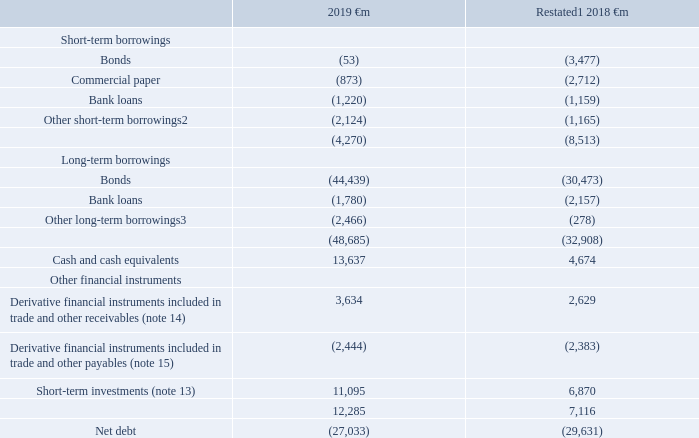20. Borrowings and capital resources
The Group’s sources of borrowing for funding and liquidity purposes come from a range of committed bank facilities and through short-term and long-term issuances in the capital markets including bond and commercial paper issues and bank loans. We manage the basis on which we incur interest on debt between fixed interest rates and floating interest rates depending on market conditions using interest rate derivatives. The Group enters into foreign exchange contracts to mitigate the impact of exchange rate movements on certain monetary items.
This section includes an analysis of net debt, which is used to manage capital
Accounting policies
Interest-bearing loans and overdrafts are initially measured at fair value (which is equal to cost at inception), and are subsequently measured at amortised cost, using the effective interest rate method. Where they are identified as a hedged item in a designated fair value hedge relationship, fair value adjustments are recognised in accordance with policy (see note 21 “Capital and financial risk management”). Any difference between the proceeds net of transaction costs and the amount due on settlement or redemption of borrowings is recognised over the term of the borrowing. Where bonds issued with certain conversion rights are identified as compound instruments they are initially measured at fair value with the nominal amounts recognised as a component in equity and the fair value of future coupons included in borrowings. These are subsequently measured at amortised cost using the effective interest rate method.
Net debt
At 31 March 2019 net debt represented 58% of our market capitalisation (2018: 46%). Average net debt at month end accounting dates over the 12-month period ended 31 March 2019 was €30.9 billion and ranged between net debt of €27.0 billion and €34.1 billion. Our consolidated net debt position at 31 March was as follows:
Notes: 1 Liabilities for payments due to holders of the equity shares in Kabel Deutschland AG under the terms of a domination and profit and loss transfer agreement are now separately disclosed in the consolidated statement of financial position and are no longer presented within short-term borrowings; gross short-term borrowings at 31 March 2018 have therefore been revised to exclude €1,838 million in respect of such liabilities.
2 At 31 March 2019 the amount includes €2,011 million (2018: €1,070 million) in relation to cash received under collateral support agreements
3 Includes €1,919 million (2018: €nil) of spectrum licence payables following the completion of recent auctions in Italy and Spain.
The fair value of the Group’s financial assets and financial liabilities held at amortised cost approximate to fair value with the exception of long-term bonds with a carrying value of €44,439 million (2018: €30,473 million) and a fair value of €43,616 million (2018: €29,724 million). Fair value is based on level 1 of the fair value hierarchy using quoted market prices.
Which financial years' information is shown in the table? 2018, 2019. What type of short term borrowings are shown in the table? Bonds, commercial paper, bank loans, other short-term borrowings. What type of long-term borrowings are shown in the table? Bonds, bank loans, other long-term borrowings. What is the average Short-term investments for 2018 and 2019?
Answer scale should be: million. (11,095+ 6,870)/2
Answer: 8982.5. What is the change in Cash and cash equivalents between 2018 and 2019?
Answer scale should be: million. 13,637-4,674
Answer: 8963. Which year has the highest value of Cash and cash equivalents?
Answer scale should be: million. 13,637> 4,674
Answer: 2019. 